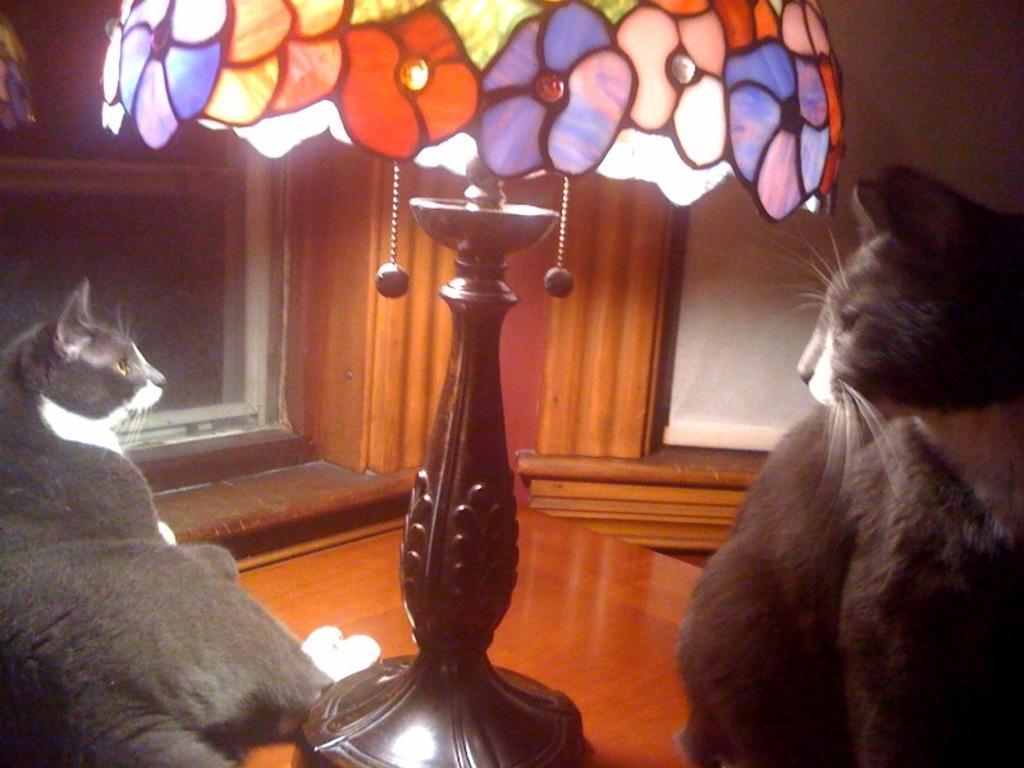In one or two sentences, can you explain what this image depicts? In the picture we can see a two cats sitting on the wooden table and the middle of it, we can see a lamp and in the background we can see a wooden wall with a window. 